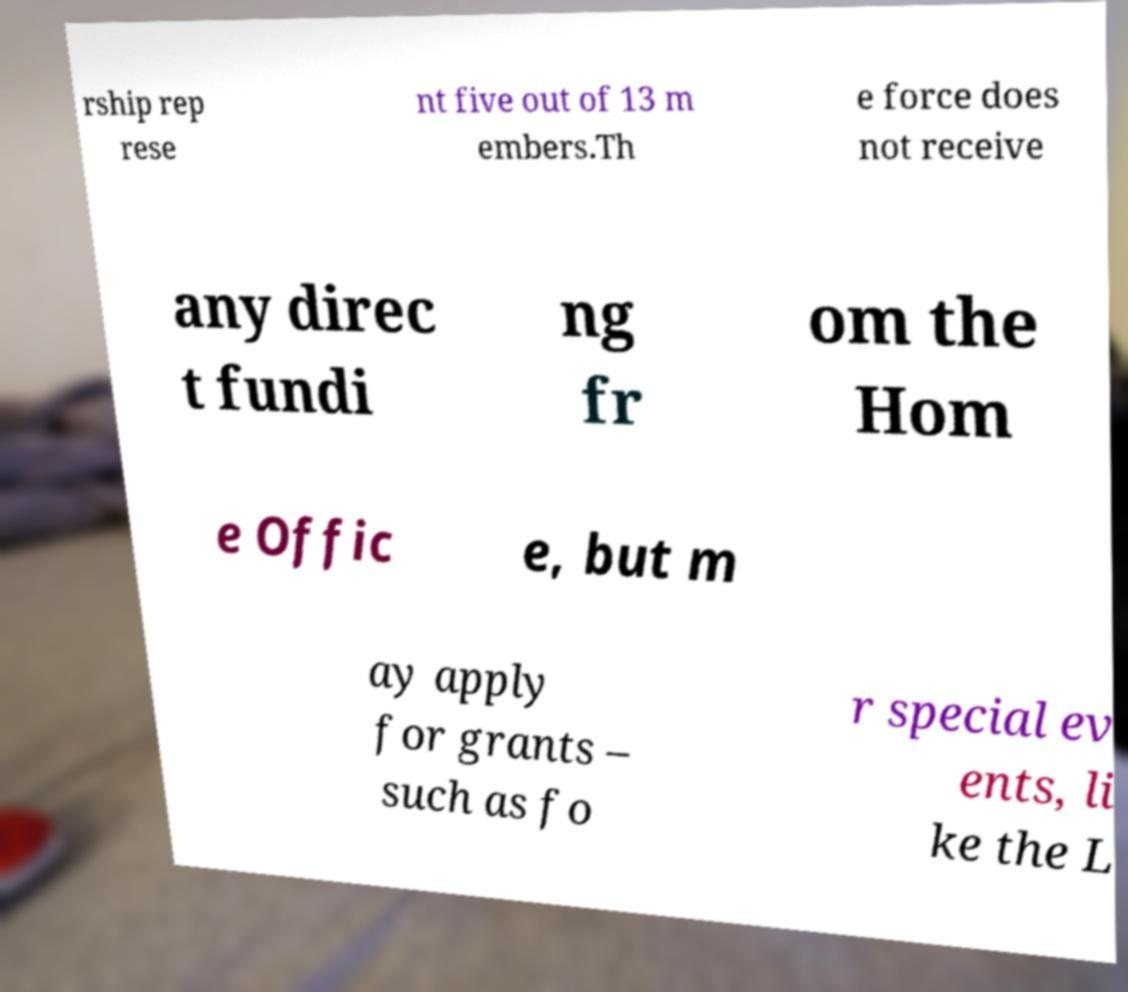For documentation purposes, I need the text within this image transcribed. Could you provide that? rship rep rese nt five out of 13 m embers.Th e force does not receive any direc t fundi ng fr om the Hom e Offic e, but m ay apply for grants – such as fo r special ev ents, li ke the L 